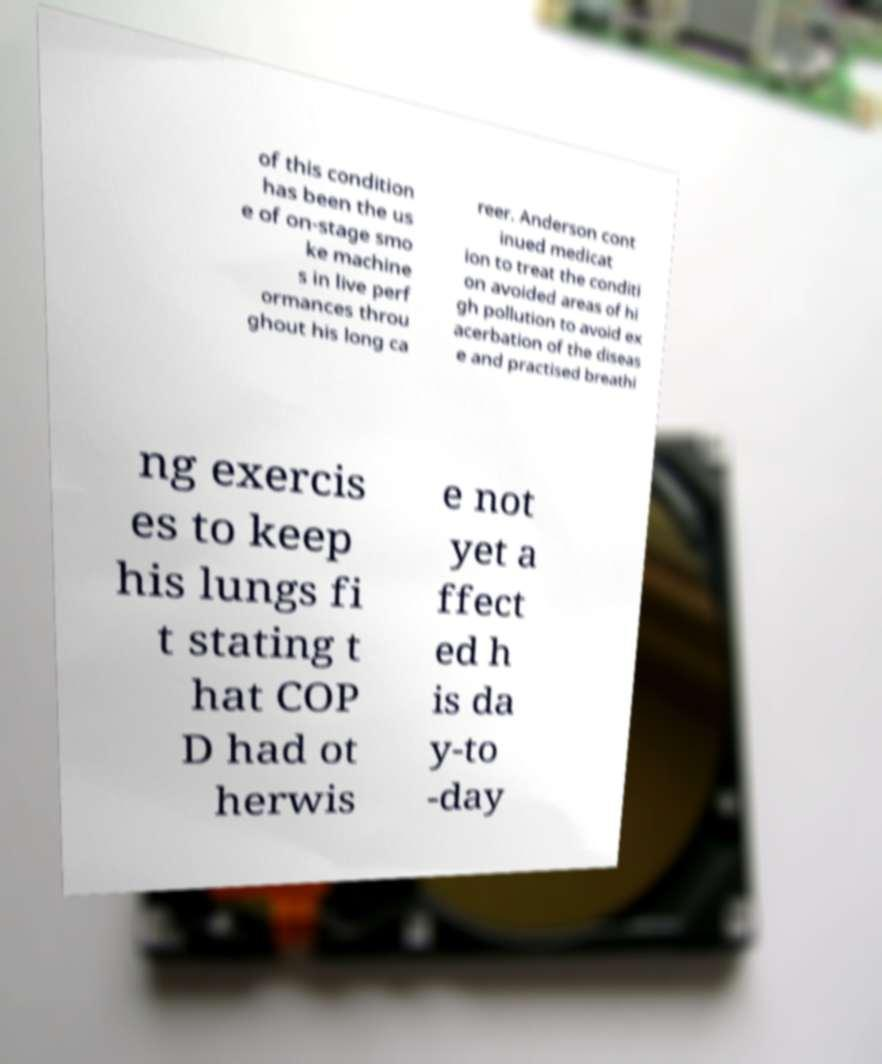For documentation purposes, I need the text within this image transcribed. Could you provide that? of this condition has been the us e of on-stage smo ke machine s in live perf ormances throu ghout his long ca reer. Anderson cont inued medicat ion to treat the conditi on avoided areas of hi gh pollution to avoid ex acerbation of the diseas e and practised breathi ng exercis es to keep his lungs fi t stating t hat COP D had ot herwis e not yet a ffect ed h is da y-to -day 